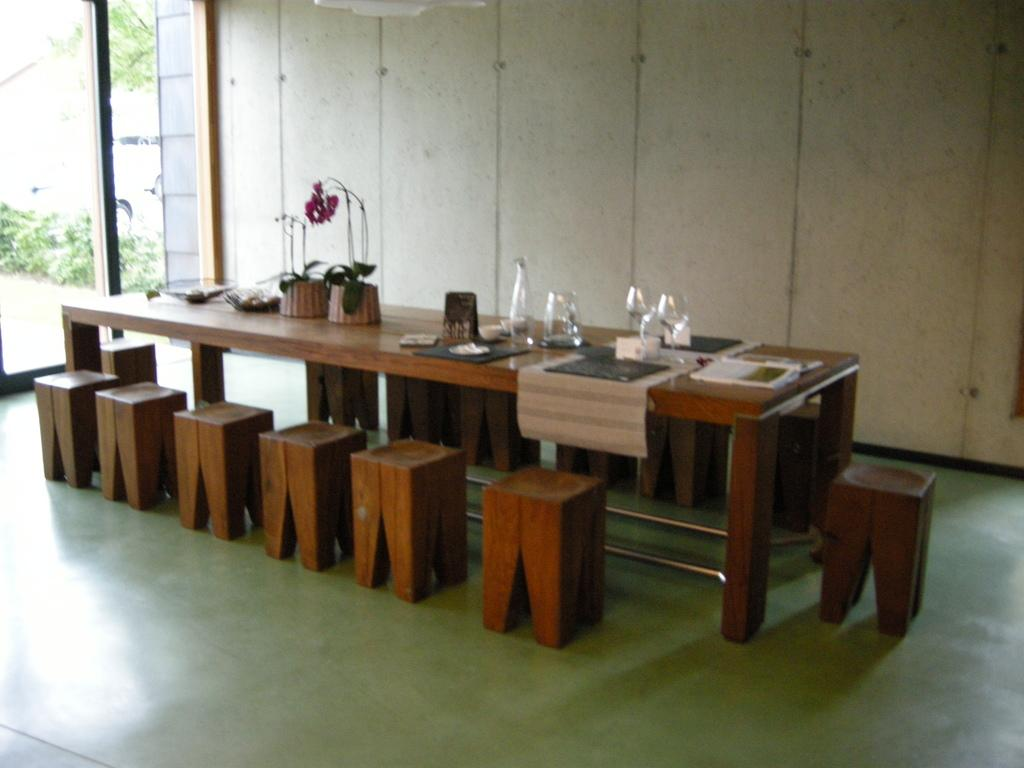What objects are in the image that are typically used for drinking? There are glasses in the image. What objects are in the image that are typically used for cooking or serving food? There are pots in the image. What type of furniture is in the middle of the image? There is a table and chairs in the middle of the image. What is the primary location of the table, chairs, glasses, and pots in the image? The table, chairs, glasses, and pots are in the middle of the image. What can be seen in the background of the image? There is a wall in the background of the image. What architectural feature is on the left side of the image? There is a glass door on the left side of the image. What type of skin condition is visible on the table in the image? There is no skin condition visible in the image; the table is a piece of furniture. 